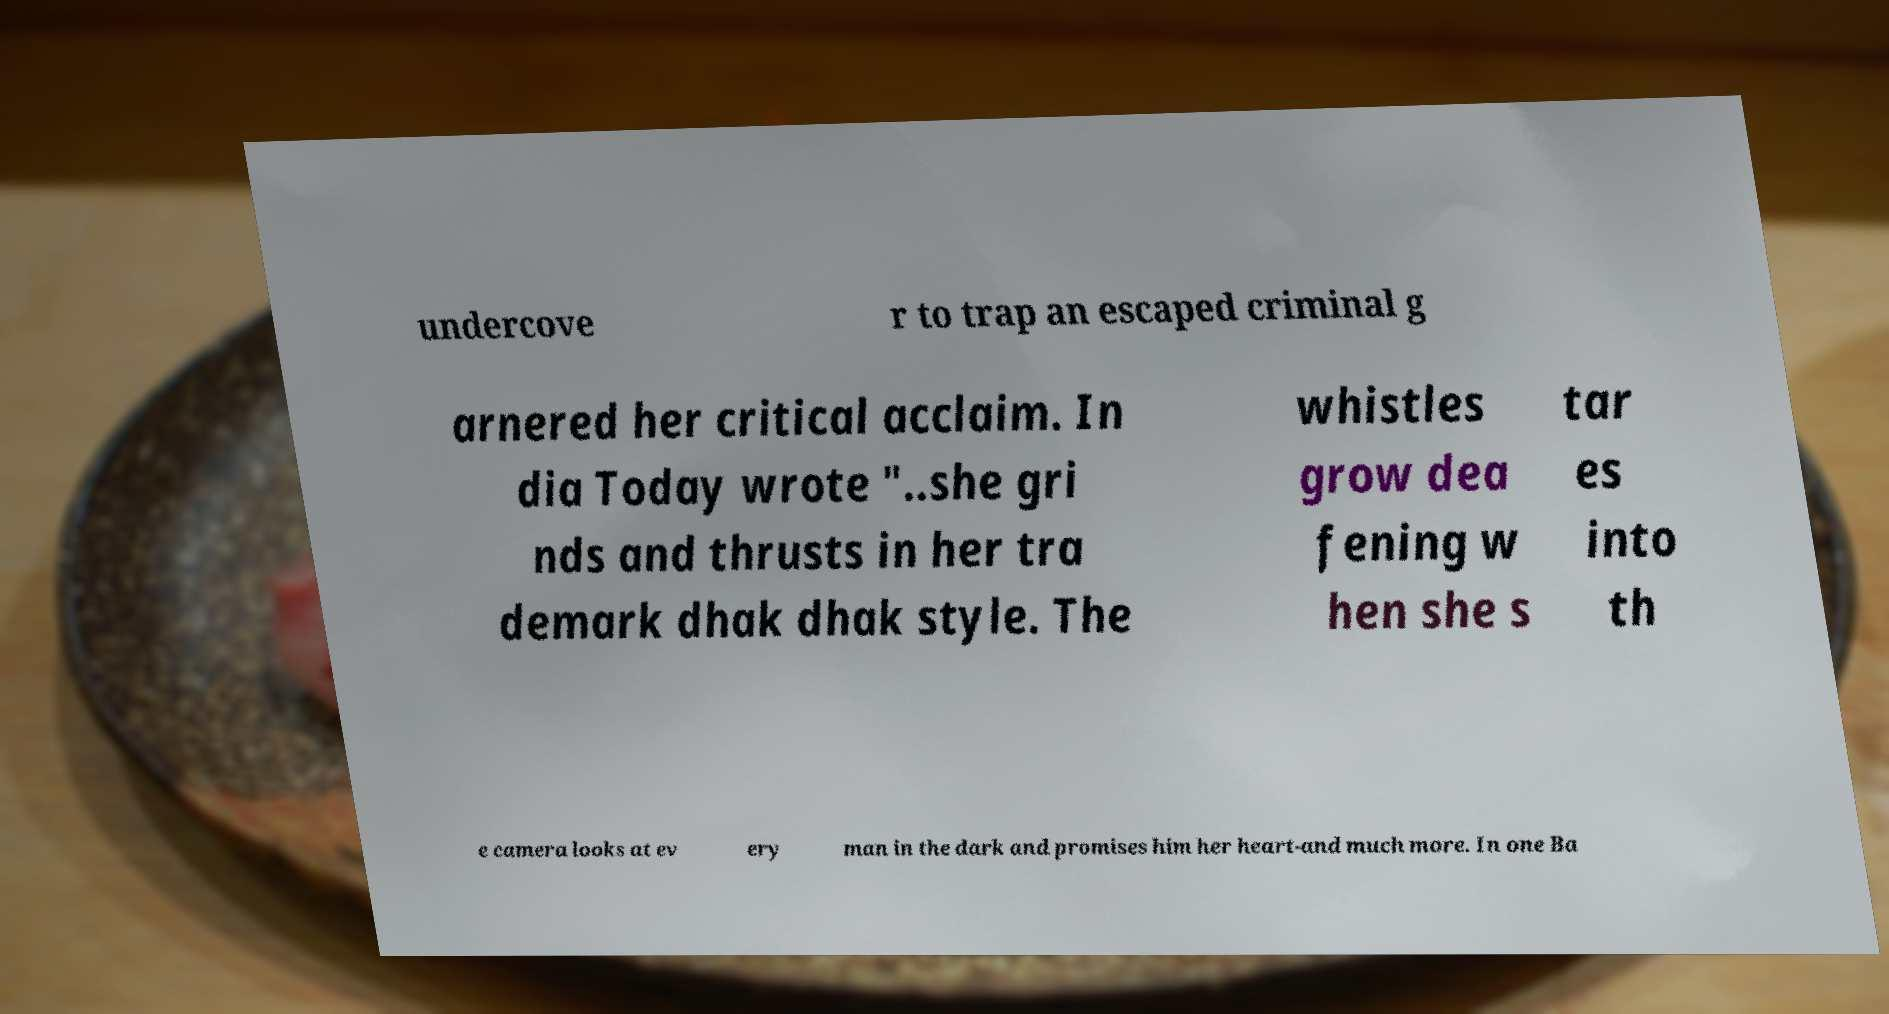Can you accurately transcribe the text from the provided image for me? undercove r to trap an escaped criminal g arnered her critical acclaim. In dia Today wrote "..she gri nds and thrusts in her tra demark dhak dhak style. The whistles grow dea fening w hen she s tar es into th e camera looks at ev ery man in the dark and promises him her heart-and much more. In one Ba 